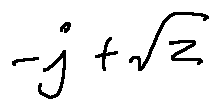Convert formula to latex. <formula><loc_0><loc_0><loc_500><loc_500>- j + \sqrt { z }</formula> 